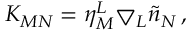Convert formula to latex. <formula><loc_0><loc_0><loc_500><loc_500>K _ { M N } = \eta _ { M } ^ { L } \bigtriangledown _ { L } \tilde { n } _ { N } \, ,</formula> 